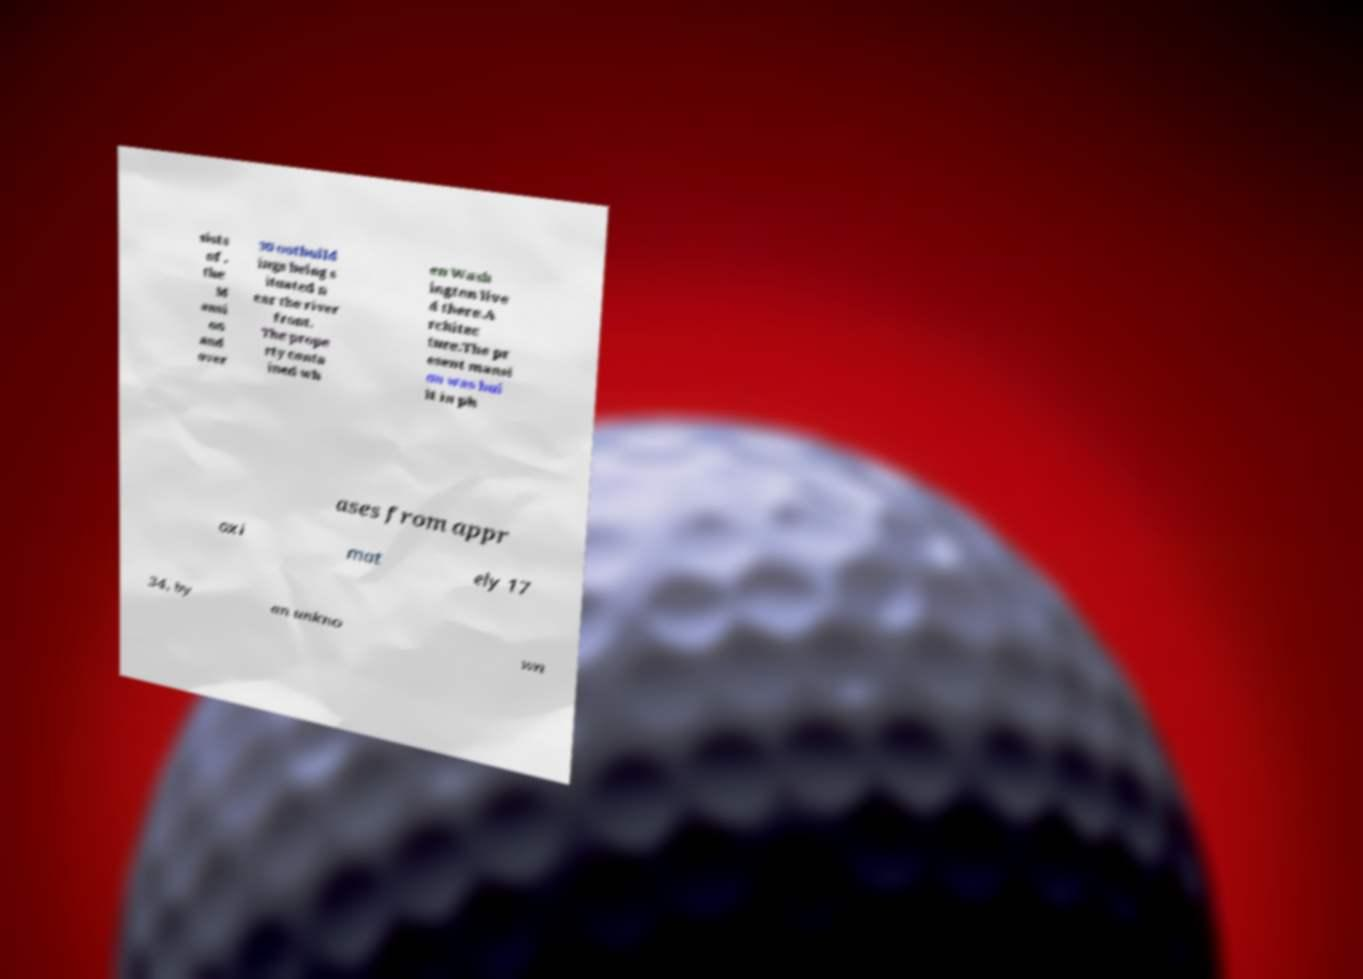Can you read and provide the text displayed in the image?This photo seems to have some interesting text. Can you extract and type it out for me? sists of , the M ansi on and over 30 outbuild ings being s ituated n ear the river front. The prope rty conta ined wh en Wash ington live d there.A rchitec ture.The pr esent mansi on was bui lt in ph ases from appr oxi mat ely 17 34, by an unkno wn 